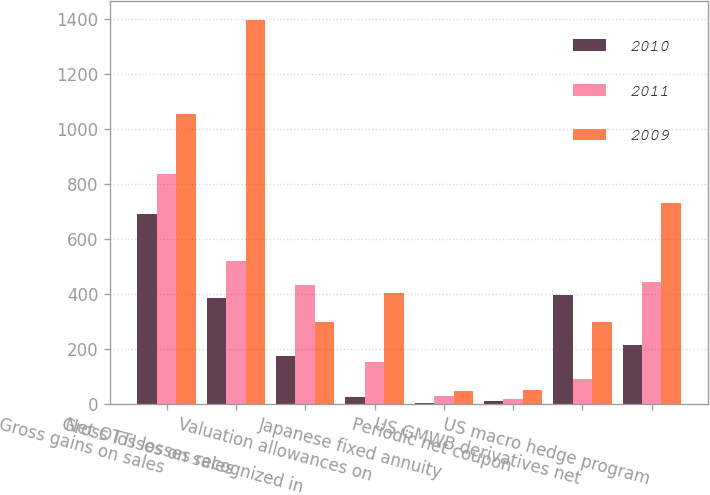<chart> <loc_0><loc_0><loc_500><loc_500><stacked_bar_chart><ecel><fcel>Gross gains on sales<fcel>Gross losses on sales<fcel>Net OTTI losses recognized in<fcel>Valuation allowances on<fcel>Japanese fixed annuity<fcel>Periodic net coupon<fcel>US GMWB derivatives net<fcel>US macro hedge program<nl><fcel>2010<fcel>693<fcel>384<fcel>174<fcel>24<fcel>3<fcel>10<fcel>397<fcel>216<nl><fcel>2011<fcel>836<fcel>522<fcel>434<fcel>154<fcel>27<fcel>17<fcel>89<fcel>445<nl><fcel>2009<fcel>1056<fcel>1397<fcel>300<fcel>403<fcel>47<fcel>49<fcel>300<fcel>733<nl></chart> 